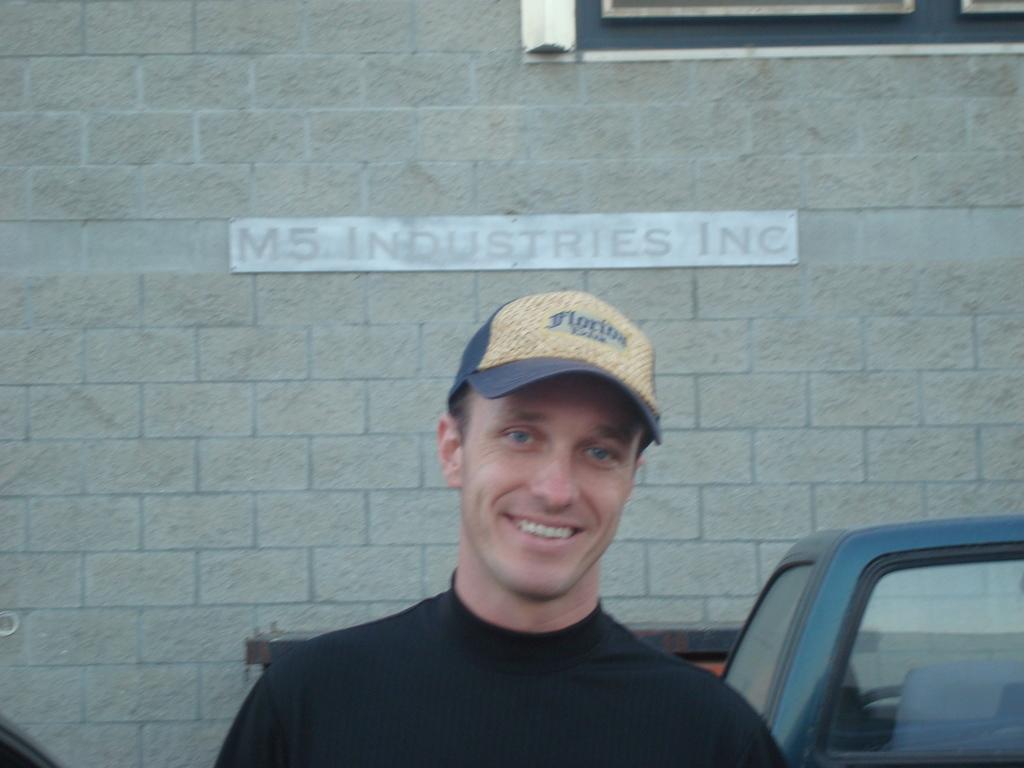Can you describe this image briefly? In the image we can see there is a person standing and he is wearing a cap. There is a car and there is a building which is made up of bricks. 